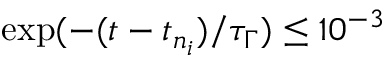<formula> <loc_0><loc_0><loc_500><loc_500>\exp ( - ( t - t _ { n _ { i } } ) / \tau _ { \Gamma } ) \leq 1 0 ^ { - 3 }</formula> 